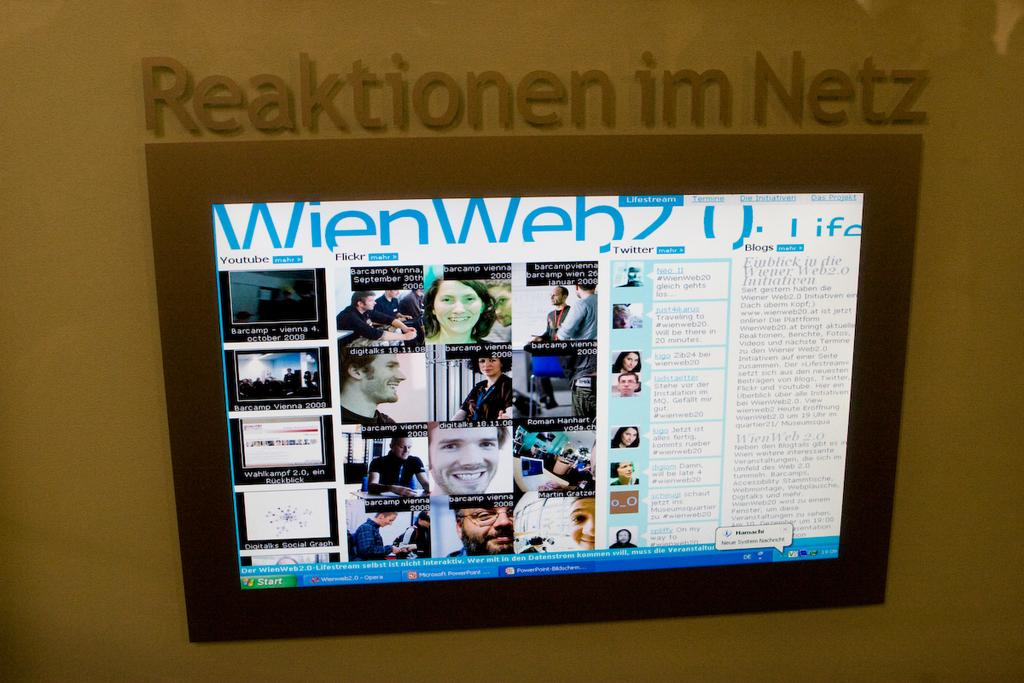<image>
Offer a succinct explanation of the picture presented. A screen with the words Reaktionen im Netz written over it 